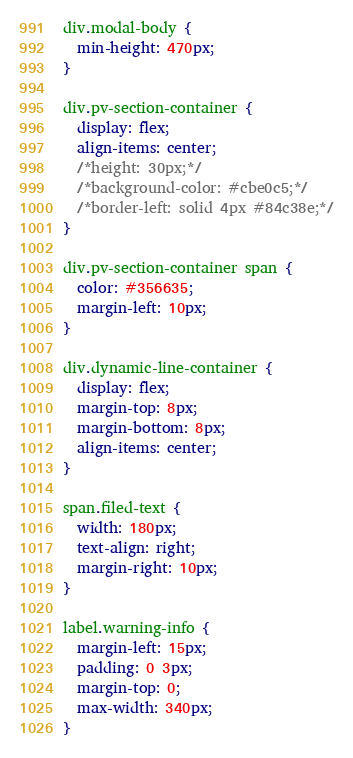Convert code to text. <code><loc_0><loc_0><loc_500><loc_500><_CSS_>div.modal-body {
  min-height: 470px;
}

div.pv-section-container {
  display: flex;
  align-items: center;
  /*height: 30px;*/
  /*background-color: #cbe0c5;*/
  /*border-left: solid 4px #84c38e;*/
}

div.pv-section-container span {
  color: #356635;
  margin-left: 10px;
}

div.dynamic-line-container {
  display: flex;
  margin-top: 8px;
  margin-bottom: 8px;
  align-items: center;
}

span.filed-text {
  width: 180px;
  text-align: right;
  margin-right: 10px;
}

label.warning-info {
  margin-left: 15px;
  padding: 0 3px;
  margin-top: 0;
  max-width: 340px;
}
</code> 